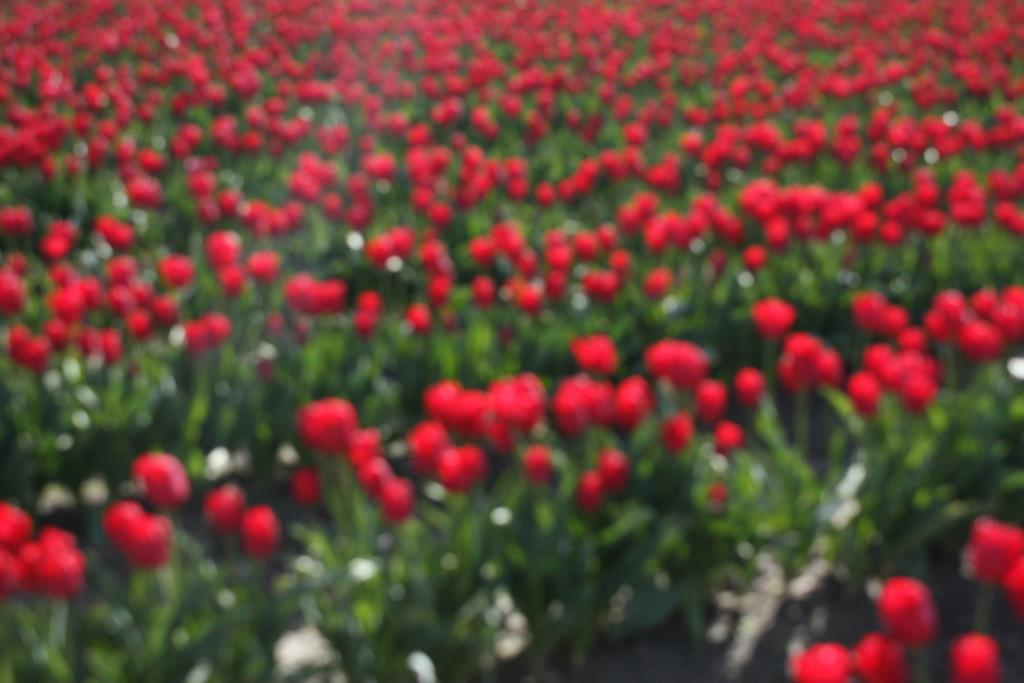What type of plants are present in the image? There are red color flower plants in the image. What type of music can be heard coming from the toys in the image? There are no toys or music present in the image; it features red color flower plants. 